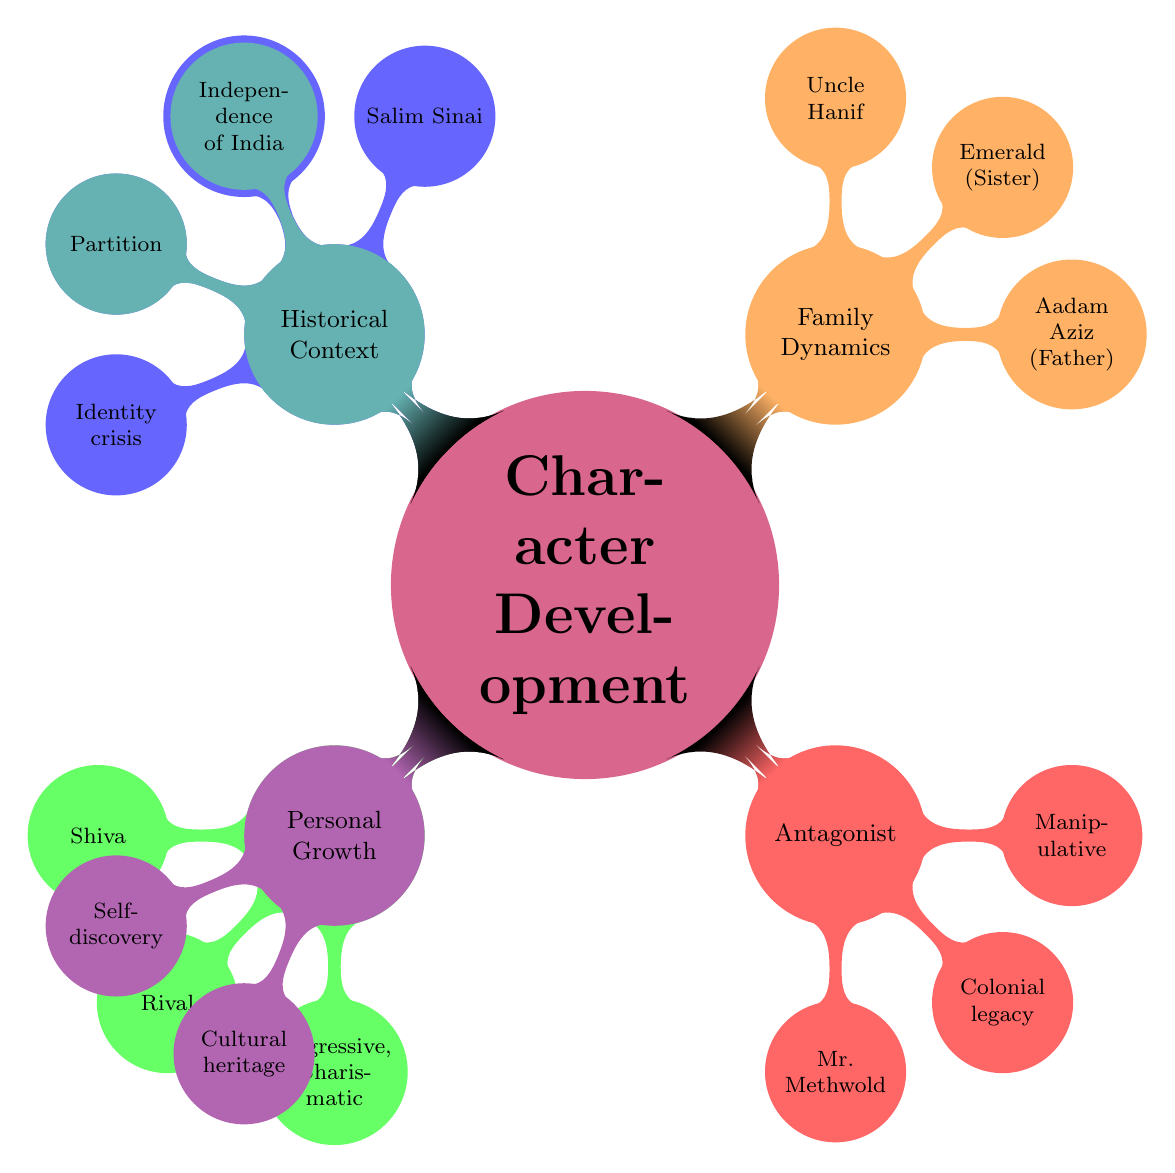What's the name of the main protagonist? The diagram clearly lists the "Main Protagonist" node, which includes the specific information of the protagonist being "Salim Sinai."
Answer: Salim Sinai What are the personality traits of the main protagonist? In the "Personality Traits" node under "Main Protagonist," three traits are listed: "Curious," "Reflective," and "Sensitive."
Answer: Curious, Reflective, Sensitive Who is the antagonist in the story? The diagram designates "Antagonist" as a distinct node, identifying "Mr. Methwold" specifically.
Answer: Mr. Methwold What role does Aadam Aziz play in the family dynamics? The "Family Dynamics" node details that Aadam Aziz, listed as "Father," serves as a "Guiding force," indicating his supportive role in the family.
Answer: Guiding force What major event influences the protagonist's identity? The "Historical Context" section includes "Independence of India," which directly states its impact on the protagonist's formation of identity, making it the key event.
Answer: Independence of India How are Salim Sinai and Shiva related in terms of their backstory? The diagram illustrates that "Salim Sinai" and "Shiva" share a "Rival" relationship, highlighted in the "Supporting Characters" section, both having been born at the same moment.
Answer: Rival What are the achievements linked to personal growth for Salim? Within the "Personal Growth" section, two noteworthy achievements are indicated: "Understanding his powers" and "Reuniting family," representing aspects of his character development.
Answer: Understanding his powers, Reuniting family Which character is described as a "Symbol of colonial legacy"? The "Antagonist" node specifically characterizes Mr. Methwold as being a "Symbol of colonial legacy," delineating a clear thematic role for this character.
Answer: Symbol of colonial legacy What is the relationship between Salim and Emerald? The "Immediate Family" section explains that Emerald, related as the "Sister" of Salim Sinai, plays a significant familial role.
Answer: Sister 